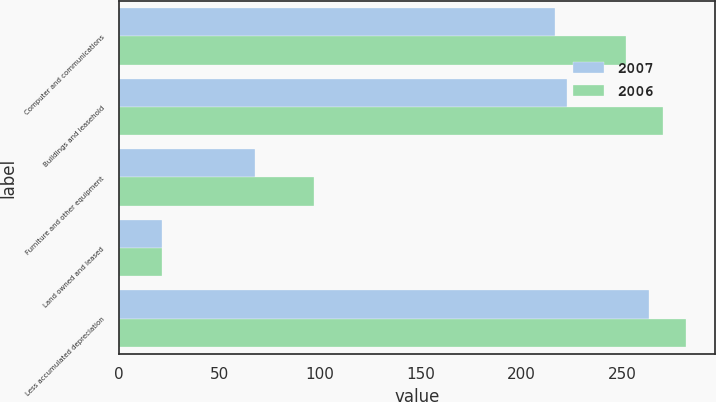Convert chart. <chart><loc_0><loc_0><loc_500><loc_500><stacked_bar_chart><ecel><fcel>Computer and communications<fcel>Buildings and leasehold<fcel>Furniture and other equipment<fcel>Land owned and leased<fcel>Less accumulated depreciation<nl><fcel>2007<fcel>216.6<fcel>222.3<fcel>67.7<fcel>21.5<fcel>263.2<nl><fcel>2006<fcel>251.5<fcel>270<fcel>97<fcel>21.5<fcel>281.7<nl></chart> 